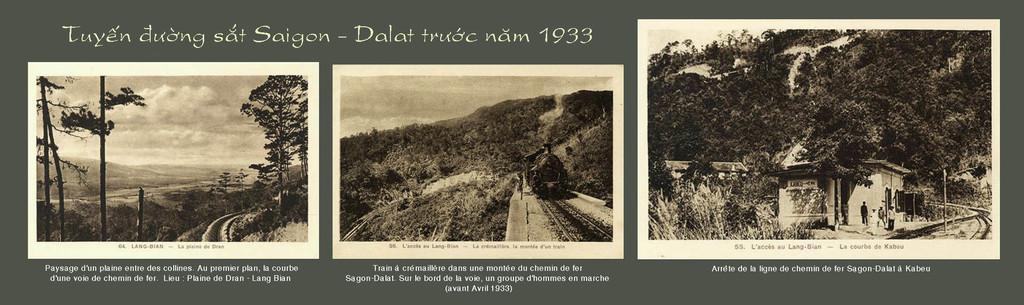Could you give a brief overview of what you see in this image? In this picture we can see a poster, in the poster we can find few trees, a train, houses and few people, at the top and bottom of the image we can find some text, also we can see clouds. 